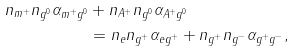<formula> <loc_0><loc_0><loc_500><loc_500>n _ { m ^ { + } } n _ { g ^ { 0 } } \alpha _ { m ^ { + } g ^ { 0 } } & + n _ { A ^ { + } } n _ { g ^ { 0 } } \alpha _ { A ^ { + } g ^ { 0 } } \\ & = n _ { e } n _ { g ^ { + } } \alpha _ { e g ^ { + } } + n _ { g ^ { + } } n _ { g ^ { - } } \alpha _ { g ^ { + } g ^ { - } } ,</formula> 